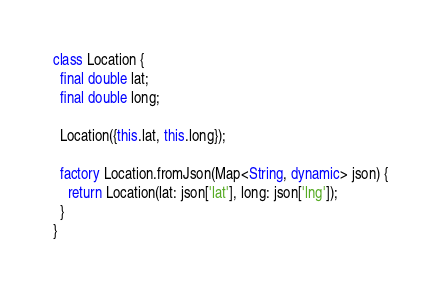<code> <loc_0><loc_0><loc_500><loc_500><_Dart_>class Location {
  final double lat;
  final double long;

  Location({this.lat, this.long});

  factory Location.fromJson(Map<String, dynamic> json) {
    return Location(lat: json['lat'], long: json['lng']);
  }
}
</code> 